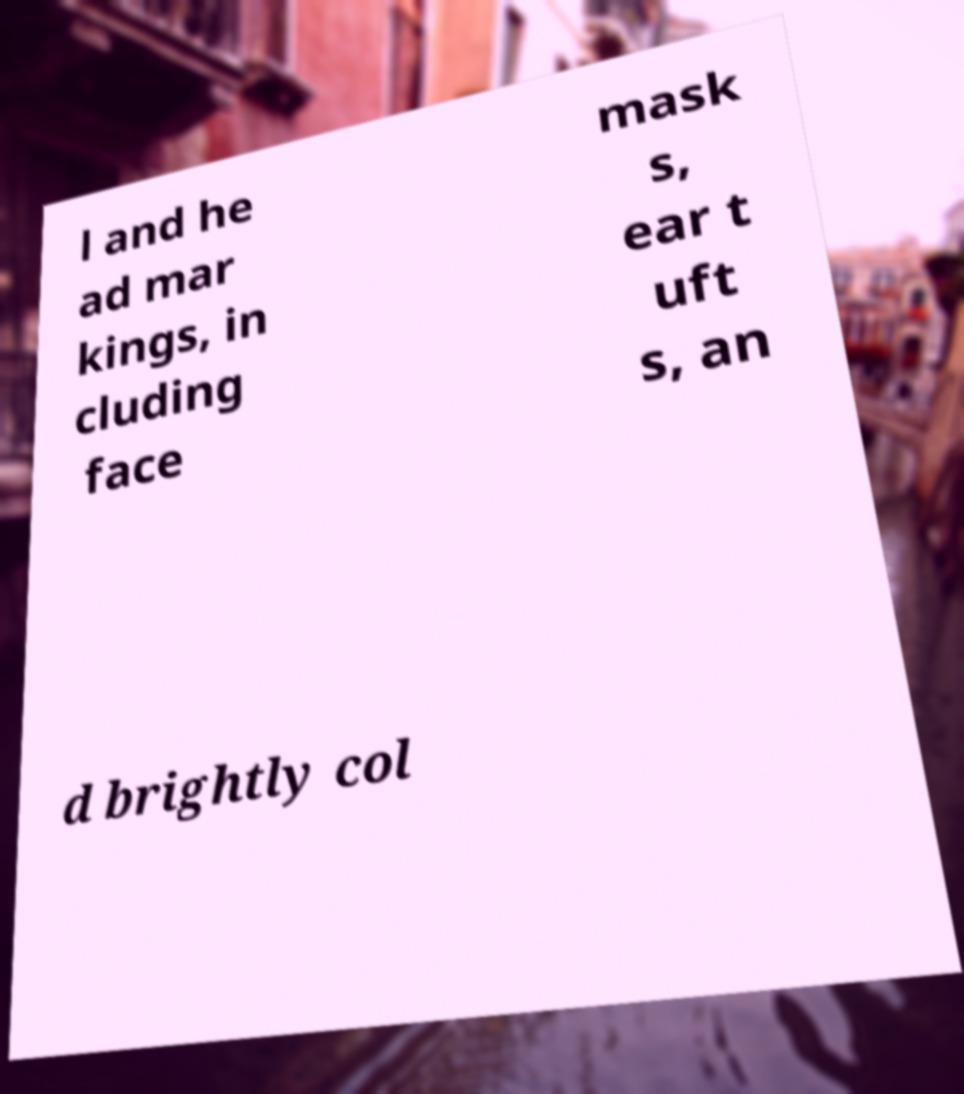For documentation purposes, I need the text within this image transcribed. Could you provide that? l and he ad mar kings, in cluding face mask s, ear t uft s, an d brightly col 